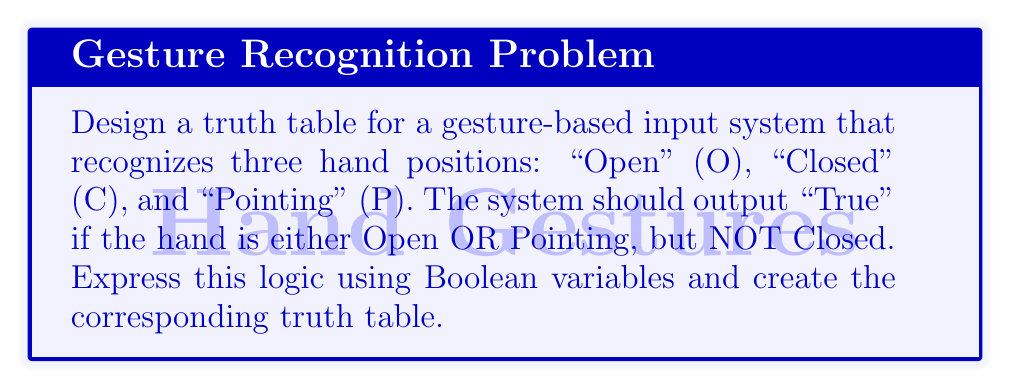Provide a solution to this math problem. Let's approach this step-by-step:

1) First, we need to define our Boolean variables:
   O: Hand is Open (1 if true, 0 if false)
   C: Hand is Closed (1 if true, 0 if false)
   P: Hand is Pointing (1 if true, 0 if false)

2) The logic we want to implement is: (O OR P) AND (NOT C)
   In Boolean algebra, this can be written as: $$(O + P) \cdot \overline{C}$$

3) Now, let's create the truth table. We'll have 3 input columns (O, C, P) and 1 output column.

4) There are $2^3 = 8$ possible combinations of inputs:

   | O | C | P | $(O + P) \cdot \overline{C}$ |
   |---|---|---|--------------------------|
   | 0 | 0 | 0 | 0 |
   | 0 | 0 | 1 | 1 |
   | 0 | 1 | 0 | 0 |
   | 0 | 1 | 1 | 0 |
   | 1 | 0 | 0 | 1 |
   | 1 | 0 | 1 | 1 |
   | 1 | 1 | 0 | 0 |
   | 1 | 1 | 1 | 0 |

5) To calculate each output:
   - First, evaluate $(O + P)$
   - Then, evaluate $\overline{C}$ (NOT C)
   - Finally, AND these results

For example, in the second row:
- $O + P = 0 + 1 = 1$
- $\overline{C} = \overline{0} = 1$
- $(O + P) \cdot \overline{C} = 1 \cdot 1 = 1$

This truth table accurately represents the desired logic for the gesture-based input system.
Answer: $$(O + P) \cdot \overline{C}$$ 